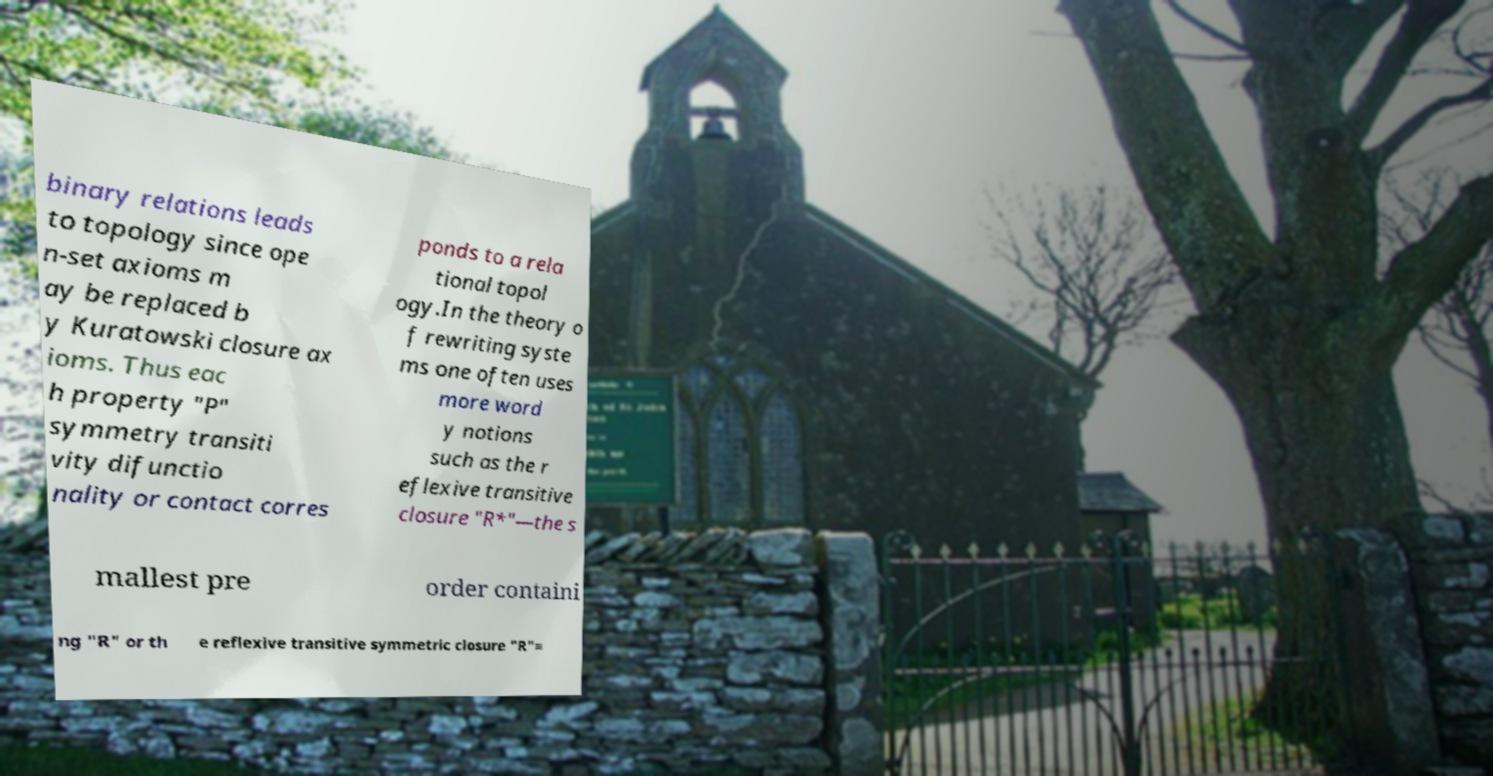Can you read and provide the text displayed in the image?This photo seems to have some interesting text. Can you extract and type it out for me? binary relations leads to topology since ope n-set axioms m ay be replaced b y Kuratowski closure ax ioms. Thus eac h property "P" symmetry transiti vity difunctio nality or contact corres ponds to a rela tional topol ogy.In the theory o f rewriting syste ms one often uses more word y notions such as the r eflexive transitive closure "R*"—the s mallest pre order containi ng "R" or th e reflexive transitive symmetric closure "R"≡ 